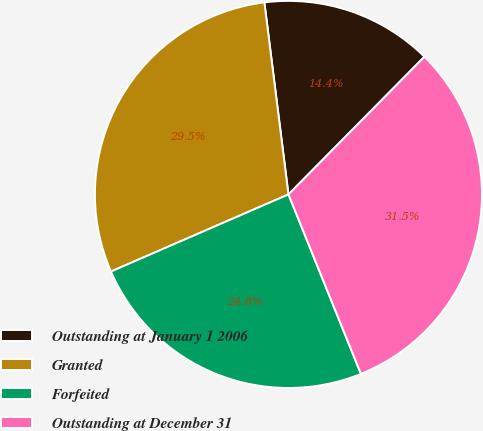<chart> <loc_0><loc_0><loc_500><loc_500><pie_chart><fcel>Outstanding at January 1 2006<fcel>Granted<fcel>Forfeited<fcel>Outstanding at December 31<nl><fcel>14.39%<fcel>29.54%<fcel>24.59%<fcel>31.49%<nl></chart> 